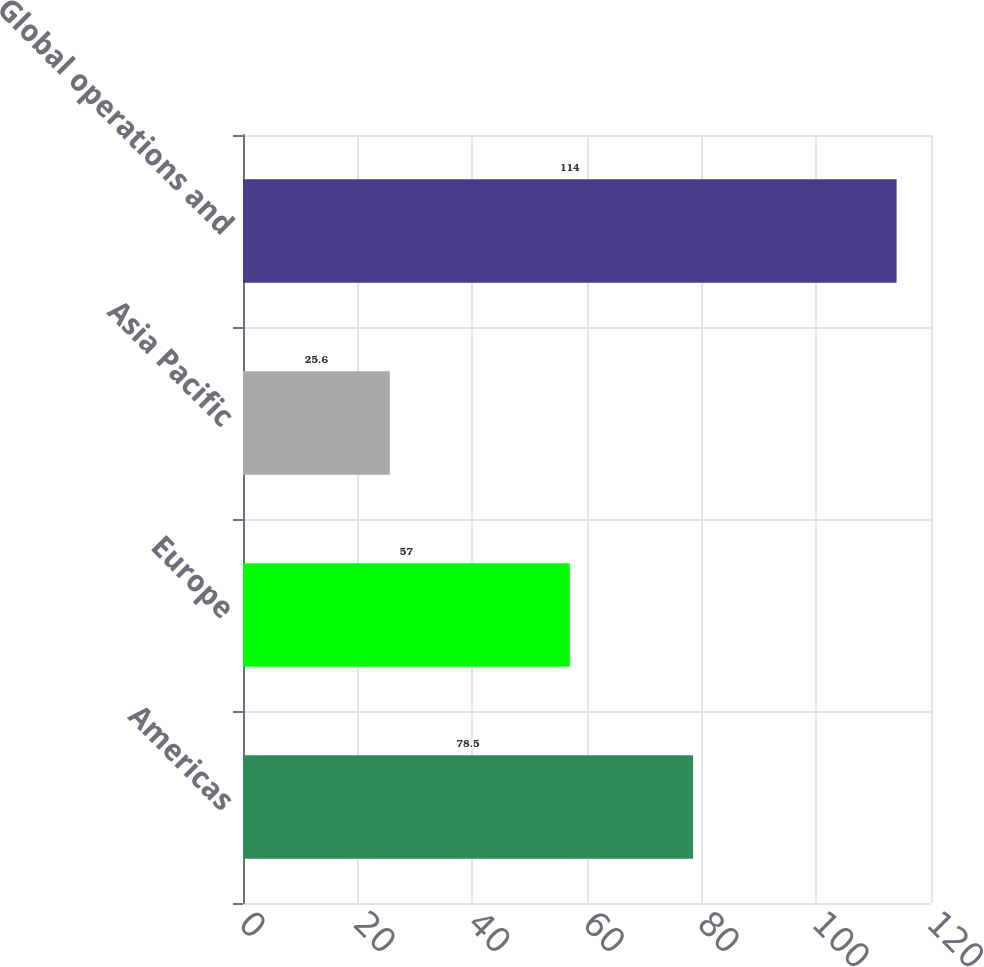Convert chart to OTSL. <chart><loc_0><loc_0><loc_500><loc_500><bar_chart><fcel>Americas<fcel>Europe<fcel>Asia Pacific<fcel>Global operations and<nl><fcel>78.5<fcel>57<fcel>25.6<fcel>114<nl></chart> 